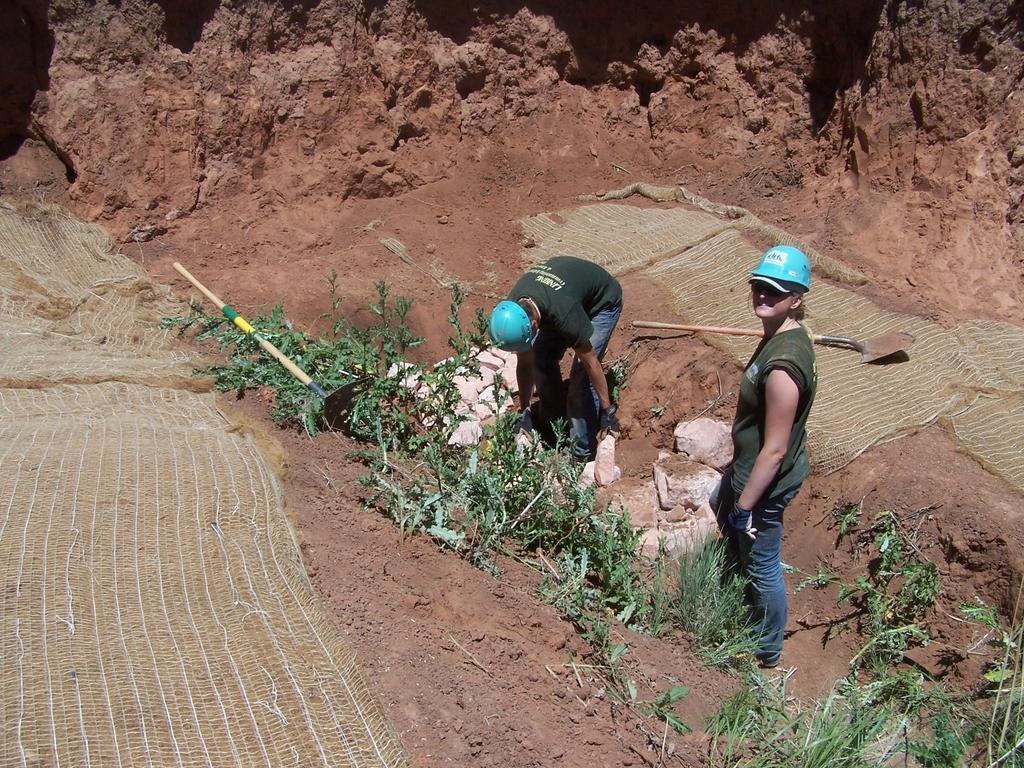Can you describe this image briefly? In the image I can see two people who are wearing the helmets and around there are some rocks, plants and some other things around. 